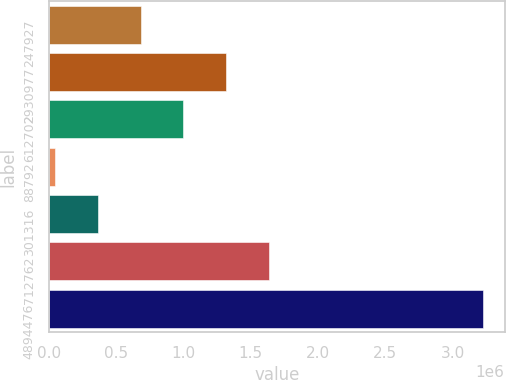<chart> <loc_0><loc_0><loc_500><loc_500><bar_chart><fcel>247927<fcel>2930977<fcel>612702<fcel>88792<fcel>301316<fcel>712762<fcel>4894476<nl><fcel>681581<fcel>1.31747e+06<fcel>999525<fcel>45693<fcel>363637<fcel>1.63541e+06<fcel>3.22513e+06<nl></chart> 